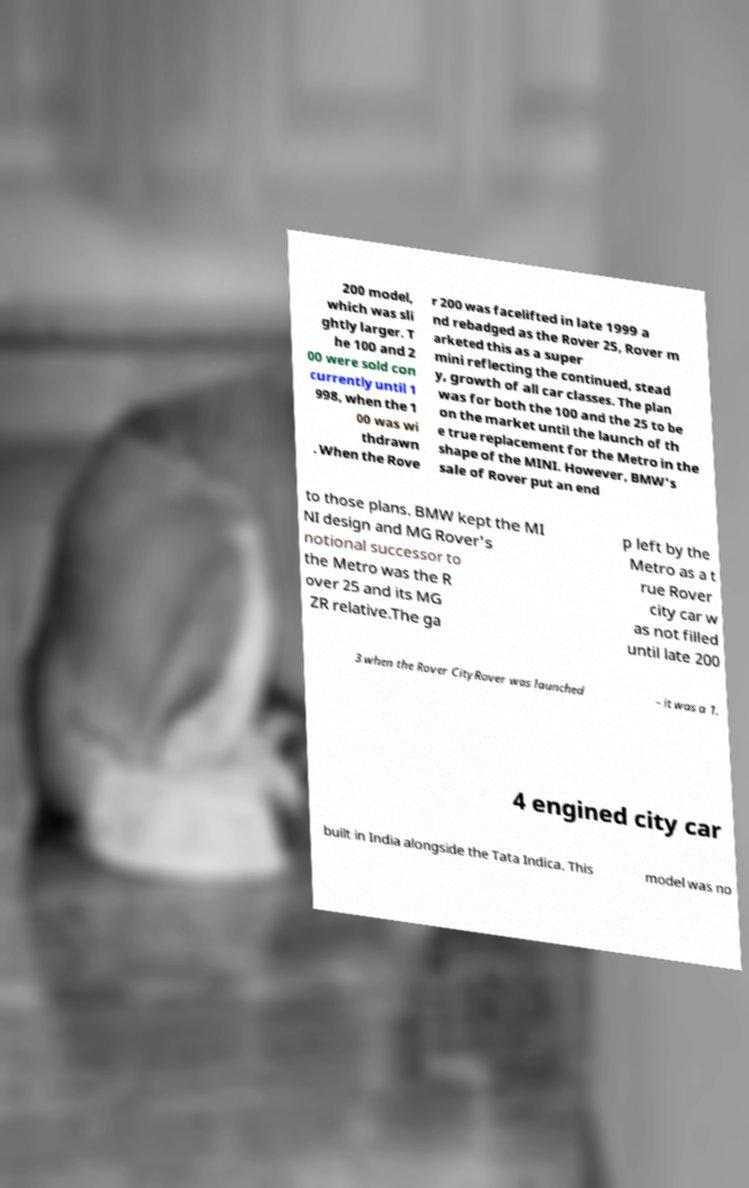I need the written content from this picture converted into text. Can you do that? 200 model, which was sli ghtly larger. T he 100 and 2 00 were sold con currently until 1 998, when the 1 00 was wi thdrawn . When the Rove r 200 was facelifted in late 1999 a nd rebadged as the Rover 25, Rover m arketed this as a super mini reflecting the continued, stead y, growth of all car classes. The plan was for both the 100 and the 25 to be on the market until the launch of th e true replacement for the Metro in the shape of the MINI. However, BMW's sale of Rover put an end to those plans. BMW kept the MI NI design and MG Rover's notional successor to the Metro was the R over 25 and its MG ZR relative.The ga p left by the Metro as a t rue Rover city car w as not filled until late 200 3 when the Rover CityRover was launched – it was a 1. 4 engined city car built in India alongside the Tata Indica. This model was no 